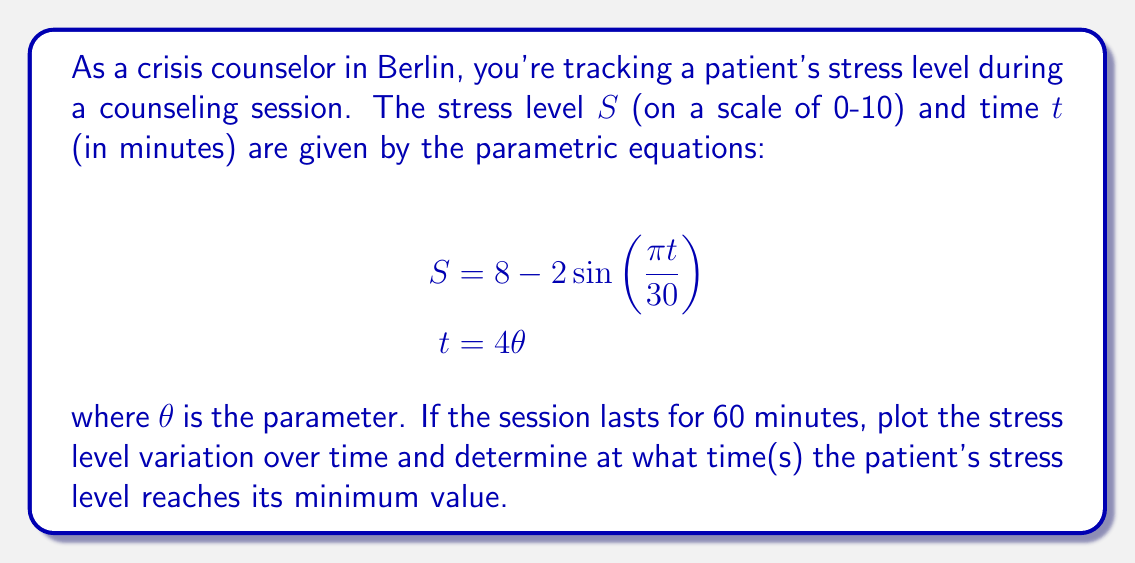Help me with this question. To solve this problem, we'll follow these steps:

1) First, let's understand the given equations:
   $S = 8 - 2\sin(\frac{\pi t}{30})$ represents the stress level
   $t = 4\theta$ represents the time

2) To plot the stress level variation over time, we need to eliminate $\theta$:
   Substitute $t = 4\theta$ into the stress equation:
   $$S = 8 - 2\sin(\frac{\pi (4\theta)}{30}) = 8 - 2\sin(\frac{2\pi \theta}{15})$$

3) Now we have $S$ in terms of $t$:
   $$S = 8 - 2\sin(\frac{\pi t}{60})$$

4) To plot this, we can use Asymptote:

[asy]
import graph;
size(200,150);
real f(real x) {return 8 - 2*sin(pi*x/60);}
draw(graph(f,0,60));
xaxis("Time (minutes)",Ticks());
yaxis("Stress Level",Ticks());
[/asy]

5) To find the minimum stress level, we need to find when $\sin(\frac{\pi t}{60})$ is at its maximum (1), as this term is subtracted.

6) $\sin(\frac{\pi t}{60})$ reaches its maximum when $\frac{\pi t}{60} = \frac{\pi}{2}$ or $\frac{3\pi}{2}$.

7) Solving for t:
   For $\frac{\pi t}{60} = \frac{\pi}{2}$: $t = 30$ minutes
   For $\frac{\pi t}{60} = \frac{3\pi}{2}$: $t = 90$ minutes, but this is outside our 60-minute session.

Therefore, the stress level reaches its minimum at t = 30 minutes.
Answer: The patient's stress level reaches its minimum value at 30 minutes into the 60-minute counseling session. 